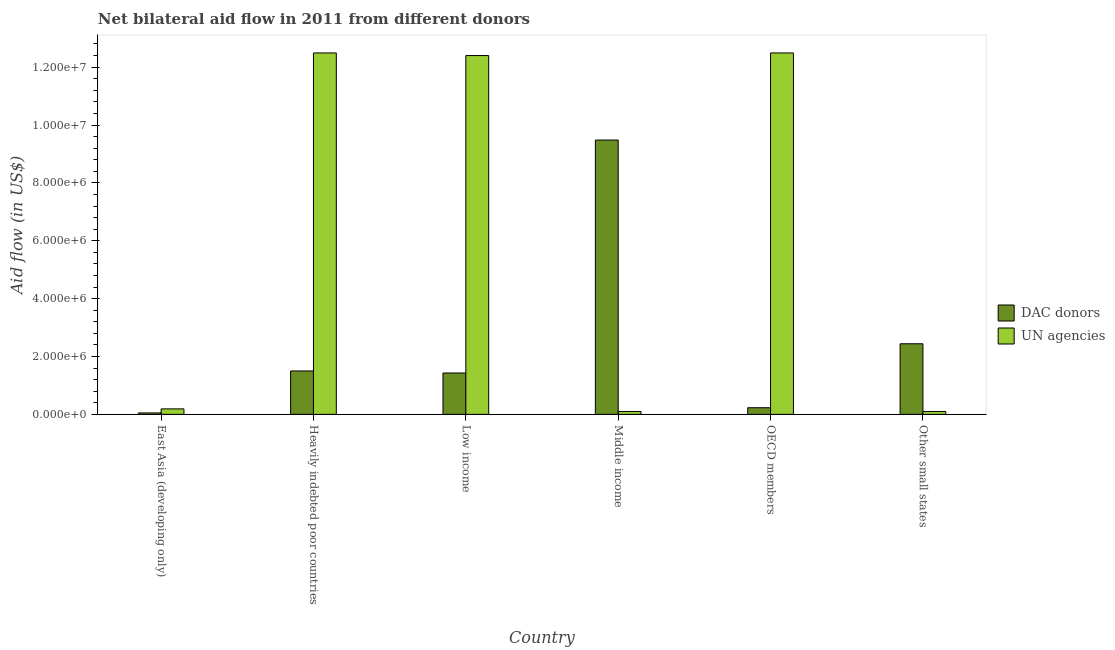Are the number of bars per tick equal to the number of legend labels?
Your answer should be compact. Yes. What is the label of the 1st group of bars from the left?
Your answer should be very brief. East Asia (developing only). What is the aid flow from dac donors in Heavily indebted poor countries?
Your answer should be compact. 1.50e+06. Across all countries, what is the maximum aid flow from un agencies?
Ensure brevity in your answer.  1.25e+07. Across all countries, what is the minimum aid flow from dac donors?
Ensure brevity in your answer.  5.00e+04. In which country was the aid flow from un agencies maximum?
Provide a short and direct response. Heavily indebted poor countries. What is the total aid flow from dac donors in the graph?
Your response must be concise. 1.51e+07. What is the difference between the aid flow from un agencies in Heavily indebted poor countries and that in Low income?
Ensure brevity in your answer.  9.00e+04. What is the difference between the aid flow from dac donors in Heavily indebted poor countries and the aid flow from un agencies in Other small states?
Offer a very short reply. 1.40e+06. What is the average aid flow from dac donors per country?
Give a very brief answer. 2.52e+06. What is the difference between the aid flow from dac donors and aid flow from un agencies in Other small states?
Give a very brief answer. 2.34e+06. What is the ratio of the aid flow from dac donors in East Asia (developing only) to that in OECD members?
Offer a terse response. 0.22. What is the difference between the highest and the lowest aid flow from un agencies?
Your response must be concise. 1.24e+07. In how many countries, is the aid flow from un agencies greater than the average aid flow from un agencies taken over all countries?
Provide a short and direct response. 3. What does the 1st bar from the left in Other small states represents?
Give a very brief answer. DAC donors. What does the 2nd bar from the right in OECD members represents?
Offer a terse response. DAC donors. How many bars are there?
Your answer should be compact. 12. Are all the bars in the graph horizontal?
Offer a very short reply. No. What is the difference between two consecutive major ticks on the Y-axis?
Keep it short and to the point. 2.00e+06. Are the values on the major ticks of Y-axis written in scientific E-notation?
Your answer should be very brief. Yes. Does the graph contain any zero values?
Make the answer very short. No. Does the graph contain grids?
Offer a very short reply. No. How many legend labels are there?
Make the answer very short. 2. What is the title of the graph?
Ensure brevity in your answer.  Net bilateral aid flow in 2011 from different donors. What is the label or title of the X-axis?
Provide a succinct answer. Country. What is the label or title of the Y-axis?
Your answer should be very brief. Aid flow (in US$). What is the Aid flow (in US$) of DAC donors in East Asia (developing only)?
Give a very brief answer. 5.00e+04. What is the Aid flow (in US$) in UN agencies in East Asia (developing only)?
Your answer should be very brief. 1.90e+05. What is the Aid flow (in US$) of DAC donors in Heavily indebted poor countries?
Give a very brief answer. 1.50e+06. What is the Aid flow (in US$) in UN agencies in Heavily indebted poor countries?
Your response must be concise. 1.25e+07. What is the Aid flow (in US$) in DAC donors in Low income?
Provide a succinct answer. 1.43e+06. What is the Aid flow (in US$) of UN agencies in Low income?
Your response must be concise. 1.24e+07. What is the Aid flow (in US$) of DAC donors in Middle income?
Keep it short and to the point. 9.48e+06. What is the Aid flow (in US$) in UN agencies in Middle income?
Offer a terse response. 1.00e+05. What is the Aid flow (in US$) in DAC donors in OECD members?
Provide a succinct answer. 2.30e+05. What is the Aid flow (in US$) of UN agencies in OECD members?
Offer a terse response. 1.25e+07. What is the Aid flow (in US$) of DAC donors in Other small states?
Make the answer very short. 2.44e+06. What is the Aid flow (in US$) of UN agencies in Other small states?
Ensure brevity in your answer.  1.00e+05. Across all countries, what is the maximum Aid flow (in US$) in DAC donors?
Your answer should be very brief. 9.48e+06. Across all countries, what is the maximum Aid flow (in US$) of UN agencies?
Provide a succinct answer. 1.25e+07. Across all countries, what is the minimum Aid flow (in US$) in UN agencies?
Make the answer very short. 1.00e+05. What is the total Aid flow (in US$) of DAC donors in the graph?
Keep it short and to the point. 1.51e+07. What is the total Aid flow (in US$) of UN agencies in the graph?
Your response must be concise. 3.78e+07. What is the difference between the Aid flow (in US$) of DAC donors in East Asia (developing only) and that in Heavily indebted poor countries?
Give a very brief answer. -1.45e+06. What is the difference between the Aid flow (in US$) in UN agencies in East Asia (developing only) and that in Heavily indebted poor countries?
Provide a succinct answer. -1.23e+07. What is the difference between the Aid flow (in US$) of DAC donors in East Asia (developing only) and that in Low income?
Keep it short and to the point. -1.38e+06. What is the difference between the Aid flow (in US$) in UN agencies in East Asia (developing only) and that in Low income?
Keep it short and to the point. -1.22e+07. What is the difference between the Aid flow (in US$) of DAC donors in East Asia (developing only) and that in Middle income?
Give a very brief answer. -9.43e+06. What is the difference between the Aid flow (in US$) of DAC donors in East Asia (developing only) and that in OECD members?
Offer a terse response. -1.80e+05. What is the difference between the Aid flow (in US$) in UN agencies in East Asia (developing only) and that in OECD members?
Offer a very short reply. -1.23e+07. What is the difference between the Aid flow (in US$) of DAC donors in East Asia (developing only) and that in Other small states?
Your answer should be compact. -2.39e+06. What is the difference between the Aid flow (in US$) of DAC donors in Heavily indebted poor countries and that in Middle income?
Your answer should be very brief. -7.98e+06. What is the difference between the Aid flow (in US$) in UN agencies in Heavily indebted poor countries and that in Middle income?
Provide a short and direct response. 1.24e+07. What is the difference between the Aid flow (in US$) of DAC donors in Heavily indebted poor countries and that in OECD members?
Ensure brevity in your answer.  1.27e+06. What is the difference between the Aid flow (in US$) in DAC donors in Heavily indebted poor countries and that in Other small states?
Your answer should be compact. -9.40e+05. What is the difference between the Aid flow (in US$) of UN agencies in Heavily indebted poor countries and that in Other small states?
Give a very brief answer. 1.24e+07. What is the difference between the Aid flow (in US$) in DAC donors in Low income and that in Middle income?
Your answer should be compact. -8.05e+06. What is the difference between the Aid flow (in US$) of UN agencies in Low income and that in Middle income?
Give a very brief answer. 1.23e+07. What is the difference between the Aid flow (in US$) in DAC donors in Low income and that in OECD members?
Your response must be concise. 1.20e+06. What is the difference between the Aid flow (in US$) of UN agencies in Low income and that in OECD members?
Offer a terse response. -9.00e+04. What is the difference between the Aid flow (in US$) in DAC donors in Low income and that in Other small states?
Give a very brief answer. -1.01e+06. What is the difference between the Aid flow (in US$) in UN agencies in Low income and that in Other small states?
Offer a terse response. 1.23e+07. What is the difference between the Aid flow (in US$) of DAC donors in Middle income and that in OECD members?
Give a very brief answer. 9.25e+06. What is the difference between the Aid flow (in US$) in UN agencies in Middle income and that in OECD members?
Your answer should be very brief. -1.24e+07. What is the difference between the Aid flow (in US$) in DAC donors in Middle income and that in Other small states?
Keep it short and to the point. 7.04e+06. What is the difference between the Aid flow (in US$) in DAC donors in OECD members and that in Other small states?
Your response must be concise. -2.21e+06. What is the difference between the Aid flow (in US$) of UN agencies in OECD members and that in Other small states?
Your answer should be very brief. 1.24e+07. What is the difference between the Aid flow (in US$) in DAC donors in East Asia (developing only) and the Aid flow (in US$) in UN agencies in Heavily indebted poor countries?
Provide a short and direct response. -1.24e+07. What is the difference between the Aid flow (in US$) of DAC donors in East Asia (developing only) and the Aid flow (in US$) of UN agencies in Low income?
Offer a very short reply. -1.24e+07. What is the difference between the Aid flow (in US$) in DAC donors in East Asia (developing only) and the Aid flow (in US$) in UN agencies in Middle income?
Provide a succinct answer. -5.00e+04. What is the difference between the Aid flow (in US$) in DAC donors in East Asia (developing only) and the Aid flow (in US$) in UN agencies in OECD members?
Provide a short and direct response. -1.24e+07. What is the difference between the Aid flow (in US$) of DAC donors in East Asia (developing only) and the Aid flow (in US$) of UN agencies in Other small states?
Offer a terse response. -5.00e+04. What is the difference between the Aid flow (in US$) in DAC donors in Heavily indebted poor countries and the Aid flow (in US$) in UN agencies in Low income?
Your response must be concise. -1.09e+07. What is the difference between the Aid flow (in US$) of DAC donors in Heavily indebted poor countries and the Aid flow (in US$) of UN agencies in Middle income?
Your answer should be compact. 1.40e+06. What is the difference between the Aid flow (in US$) of DAC donors in Heavily indebted poor countries and the Aid flow (in US$) of UN agencies in OECD members?
Your response must be concise. -1.10e+07. What is the difference between the Aid flow (in US$) in DAC donors in Heavily indebted poor countries and the Aid flow (in US$) in UN agencies in Other small states?
Provide a succinct answer. 1.40e+06. What is the difference between the Aid flow (in US$) of DAC donors in Low income and the Aid flow (in US$) of UN agencies in Middle income?
Give a very brief answer. 1.33e+06. What is the difference between the Aid flow (in US$) in DAC donors in Low income and the Aid flow (in US$) in UN agencies in OECD members?
Offer a terse response. -1.11e+07. What is the difference between the Aid flow (in US$) in DAC donors in Low income and the Aid flow (in US$) in UN agencies in Other small states?
Keep it short and to the point. 1.33e+06. What is the difference between the Aid flow (in US$) in DAC donors in Middle income and the Aid flow (in US$) in UN agencies in OECD members?
Ensure brevity in your answer.  -3.01e+06. What is the difference between the Aid flow (in US$) of DAC donors in Middle income and the Aid flow (in US$) of UN agencies in Other small states?
Make the answer very short. 9.38e+06. What is the difference between the Aid flow (in US$) in DAC donors in OECD members and the Aid flow (in US$) in UN agencies in Other small states?
Make the answer very short. 1.30e+05. What is the average Aid flow (in US$) of DAC donors per country?
Keep it short and to the point. 2.52e+06. What is the average Aid flow (in US$) in UN agencies per country?
Provide a short and direct response. 6.30e+06. What is the difference between the Aid flow (in US$) of DAC donors and Aid flow (in US$) of UN agencies in Heavily indebted poor countries?
Ensure brevity in your answer.  -1.10e+07. What is the difference between the Aid flow (in US$) in DAC donors and Aid flow (in US$) in UN agencies in Low income?
Your answer should be compact. -1.10e+07. What is the difference between the Aid flow (in US$) of DAC donors and Aid flow (in US$) of UN agencies in Middle income?
Your answer should be very brief. 9.38e+06. What is the difference between the Aid flow (in US$) in DAC donors and Aid flow (in US$) in UN agencies in OECD members?
Provide a succinct answer. -1.23e+07. What is the difference between the Aid flow (in US$) in DAC donors and Aid flow (in US$) in UN agencies in Other small states?
Provide a short and direct response. 2.34e+06. What is the ratio of the Aid flow (in US$) in UN agencies in East Asia (developing only) to that in Heavily indebted poor countries?
Keep it short and to the point. 0.02. What is the ratio of the Aid flow (in US$) in DAC donors in East Asia (developing only) to that in Low income?
Provide a succinct answer. 0.04. What is the ratio of the Aid flow (in US$) in UN agencies in East Asia (developing only) to that in Low income?
Ensure brevity in your answer.  0.02. What is the ratio of the Aid flow (in US$) in DAC donors in East Asia (developing only) to that in Middle income?
Give a very brief answer. 0.01. What is the ratio of the Aid flow (in US$) of UN agencies in East Asia (developing only) to that in Middle income?
Your response must be concise. 1.9. What is the ratio of the Aid flow (in US$) of DAC donors in East Asia (developing only) to that in OECD members?
Your answer should be very brief. 0.22. What is the ratio of the Aid flow (in US$) of UN agencies in East Asia (developing only) to that in OECD members?
Give a very brief answer. 0.02. What is the ratio of the Aid flow (in US$) of DAC donors in East Asia (developing only) to that in Other small states?
Your answer should be compact. 0.02. What is the ratio of the Aid flow (in US$) of DAC donors in Heavily indebted poor countries to that in Low income?
Your answer should be compact. 1.05. What is the ratio of the Aid flow (in US$) of UN agencies in Heavily indebted poor countries to that in Low income?
Ensure brevity in your answer.  1.01. What is the ratio of the Aid flow (in US$) of DAC donors in Heavily indebted poor countries to that in Middle income?
Ensure brevity in your answer.  0.16. What is the ratio of the Aid flow (in US$) in UN agencies in Heavily indebted poor countries to that in Middle income?
Your response must be concise. 124.9. What is the ratio of the Aid flow (in US$) of DAC donors in Heavily indebted poor countries to that in OECD members?
Offer a very short reply. 6.52. What is the ratio of the Aid flow (in US$) of UN agencies in Heavily indebted poor countries to that in OECD members?
Keep it short and to the point. 1. What is the ratio of the Aid flow (in US$) in DAC donors in Heavily indebted poor countries to that in Other small states?
Give a very brief answer. 0.61. What is the ratio of the Aid flow (in US$) of UN agencies in Heavily indebted poor countries to that in Other small states?
Give a very brief answer. 124.9. What is the ratio of the Aid flow (in US$) in DAC donors in Low income to that in Middle income?
Ensure brevity in your answer.  0.15. What is the ratio of the Aid flow (in US$) in UN agencies in Low income to that in Middle income?
Your answer should be compact. 124. What is the ratio of the Aid flow (in US$) in DAC donors in Low income to that in OECD members?
Provide a short and direct response. 6.22. What is the ratio of the Aid flow (in US$) of UN agencies in Low income to that in OECD members?
Give a very brief answer. 0.99. What is the ratio of the Aid flow (in US$) of DAC donors in Low income to that in Other small states?
Make the answer very short. 0.59. What is the ratio of the Aid flow (in US$) in UN agencies in Low income to that in Other small states?
Provide a succinct answer. 124. What is the ratio of the Aid flow (in US$) of DAC donors in Middle income to that in OECD members?
Provide a succinct answer. 41.22. What is the ratio of the Aid flow (in US$) of UN agencies in Middle income to that in OECD members?
Give a very brief answer. 0.01. What is the ratio of the Aid flow (in US$) of DAC donors in Middle income to that in Other small states?
Give a very brief answer. 3.89. What is the ratio of the Aid flow (in US$) of DAC donors in OECD members to that in Other small states?
Provide a short and direct response. 0.09. What is the ratio of the Aid flow (in US$) in UN agencies in OECD members to that in Other small states?
Provide a succinct answer. 124.9. What is the difference between the highest and the second highest Aid flow (in US$) of DAC donors?
Make the answer very short. 7.04e+06. What is the difference between the highest and the second highest Aid flow (in US$) in UN agencies?
Ensure brevity in your answer.  0. What is the difference between the highest and the lowest Aid flow (in US$) in DAC donors?
Keep it short and to the point. 9.43e+06. What is the difference between the highest and the lowest Aid flow (in US$) in UN agencies?
Give a very brief answer. 1.24e+07. 